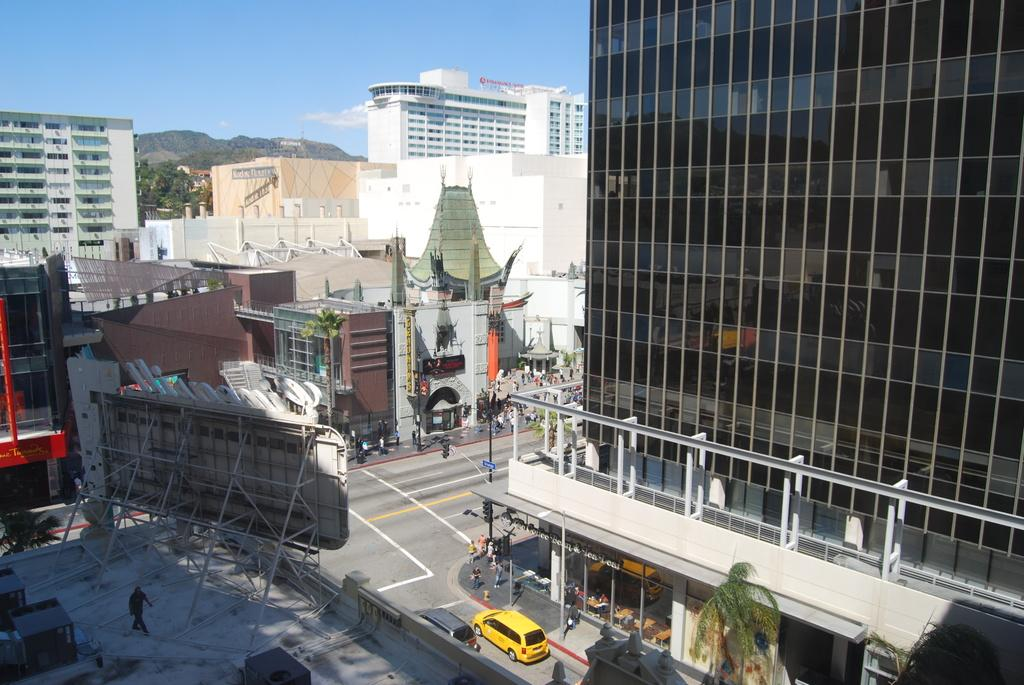What type of structures can be seen in the image? There are buildings in the image. What natural features are present in the image? There are hills and trees in the image. What man-made objects can be seen in the image? There are poles, motor vehicles, and advertisement boards in the image. What is the condition of the sky in the image? The sky is visible in the image, and there are clouds present. Are there any people visible in the image? Yes, there are persons on the road in the image. What hobbies do the clouds in the image enjoy? Clouds do not have hobbies, as they are inanimate objects. What is the reaction of the buildings to the presence of the trees? Buildings do not have reactions, as they are inanimate structures. 